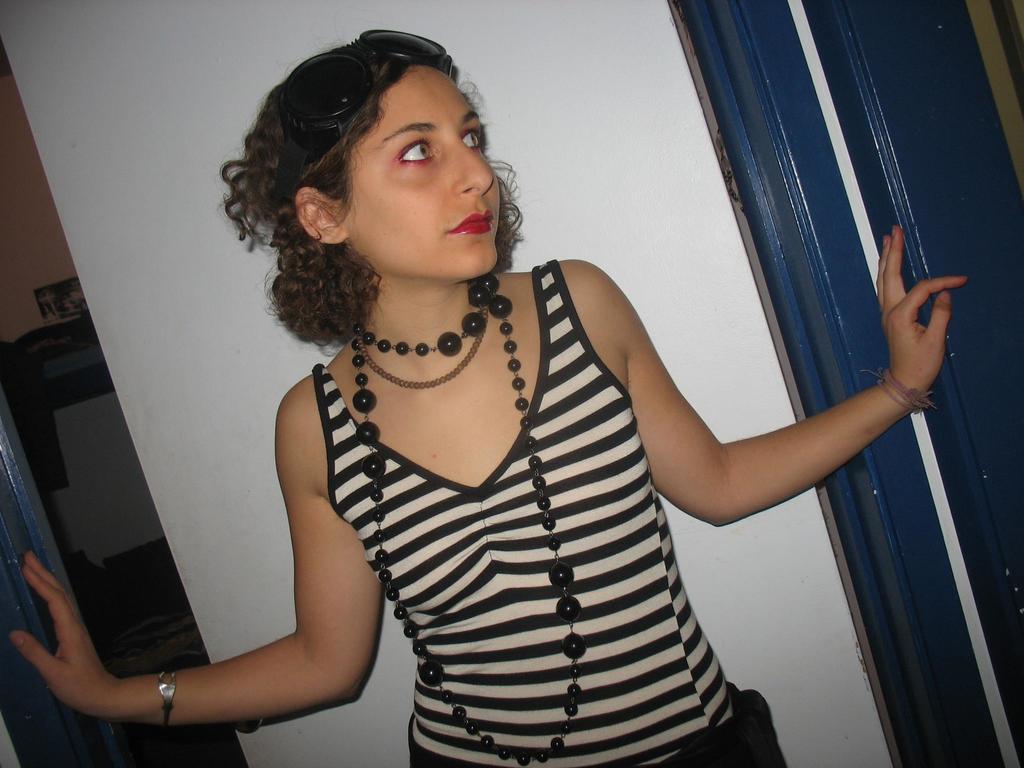Could you give a brief overview of what you see in this image? In this picture I can see a woman in front, who is standing and I see that she is wearing white and black color dress and I see she is wearing few necklace. In the background I see the wall and on the right side of this image I see the blue color things. 